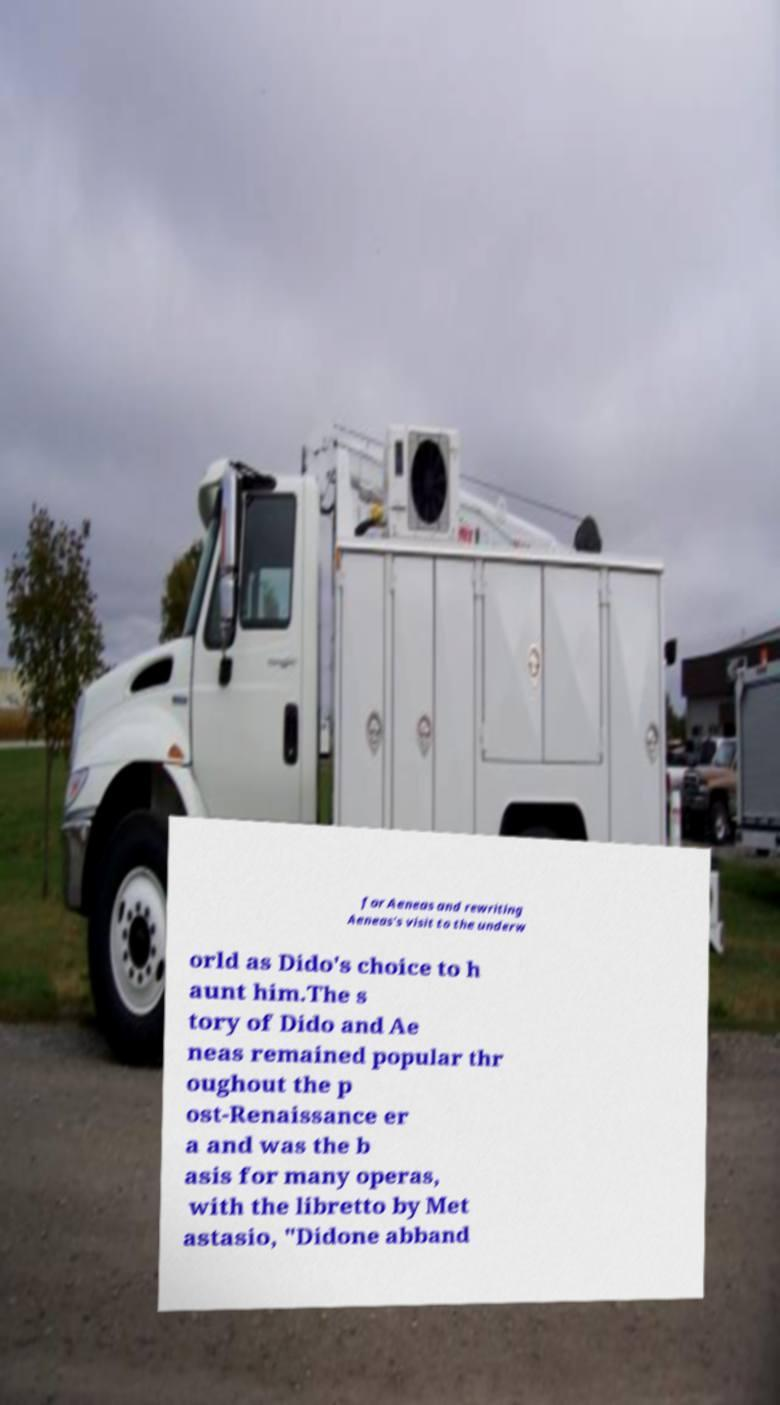Could you assist in decoding the text presented in this image and type it out clearly? for Aeneas and rewriting Aeneas's visit to the underw orld as Dido's choice to h aunt him.The s tory of Dido and Ae neas remained popular thr oughout the p ost-Renaissance er a and was the b asis for many operas, with the libretto by Met astasio, "Didone abband 